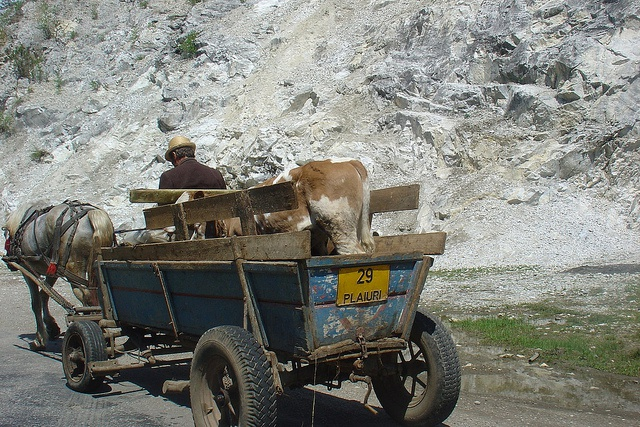Describe the objects in this image and their specific colors. I can see cow in lightblue, gray, darkgray, and maroon tones, horse in lightblue, black, gray, and darkgray tones, and people in lightblue, black, gray, and darkgray tones in this image. 